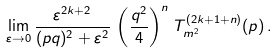Convert formula to latex. <formula><loc_0><loc_0><loc_500><loc_500>\lim _ { \varepsilon \rightarrow 0 } \frac { \varepsilon ^ { 2 k + 2 } } { ( p q ) ^ { 2 } + \varepsilon ^ { 2 } } \, \left ( \frac { q ^ { 2 } } { 4 } \right ) ^ { n } \, T _ { m ^ { 2 } } ^ { ( 2 k + 1 + n ) } ( p ) \, .</formula> 